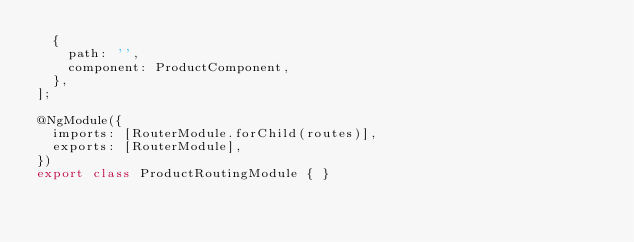Convert code to text. <code><loc_0><loc_0><loc_500><loc_500><_TypeScript_>  {
    path: '',
    component: ProductComponent,
  },
];

@NgModule({
  imports: [RouterModule.forChild(routes)],
  exports: [RouterModule],
})
export class ProductRoutingModule { }
</code> 